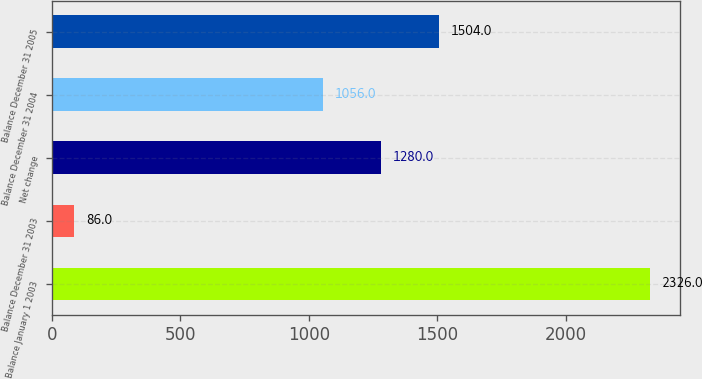Convert chart. <chart><loc_0><loc_0><loc_500><loc_500><bar_chart><fcel>Balance January 1 2003<fcel>Balance December 31 2003<fcel>Net change<fcel>Balance December 31 2004<fcel>Balance December 31 2005<nl><fcel>2326<fcel>86<fcel>1280<fcel>1056<fcel>1504<nl></chart> 